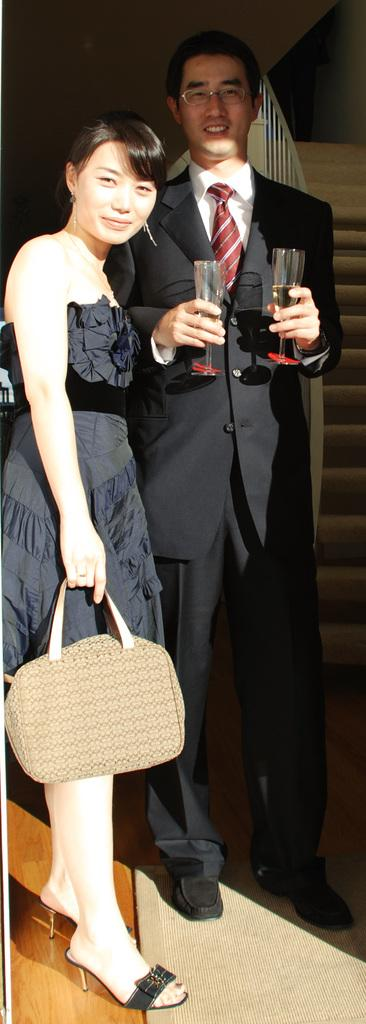What is the gender of the person in the image? There is a woman in the image. What is the woman doing in the image? The woman is standing and holding a bag in her hand. Is there another person in the image? Yes, there is a man in the image. What is the man doing in the image? The man is standing and smiling. He is also holding a glass in his hand. What can be seen in the background of the image? There are staircases in the background of the image. What nation is represented by the flag on the desk in the image? There is no flag or desk present in the image. What is the sun's position in the image? The sun is not visible in the image. 